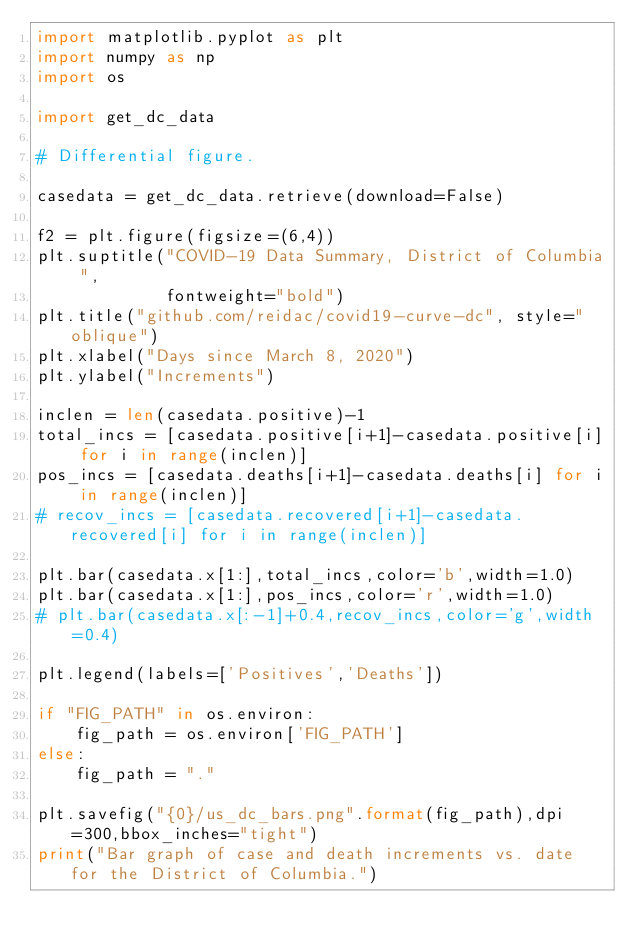Convert code to text. <code><loc_0><loc_0><loc_500><loc_500><_Python_>import matplotlib.pyplot as plt
import numpy as np
import os

import get_dc_data

# Differential figure.

casedata = get_dc_data.retrieve(download=False)

f2 = plt.figure(figsize=(6,4))
plt.suptitle("COVID-19 Data Summary, District of Columbia ",
             fontweight="bold")
plt.title("github.com/reidac/covid19-curve-dc", style="oblique")
plt.xlabel("Days since March 8, 2020")
plt.ylabel("Increments")

inclen = len(casedata.positive)-1
total_incs = [casedata.positive[i+1]-casedata.positive[i] for i in range(inclen)]
pos_incs = [casedata.deaths[i+1]-casedata.deaths[i] for i in range(inclen)]
# recov_incs = [casedata.recovered[i+1]-casedata.recovered[i] for i in range(inclen)]

plt.bar(casedata.x[1:],total_incs,color='b',width=1.0)
plt.bar(casedata.x[1:],pos_incs,color='r',width=1.0)
# plt.bar(casedata.x[:-1]+0.4,recov_incs,color='g',width=0.4)

plt.legend(labels=['Positives','Deaths'])

if "FIG_PATH" in os.environ:
    fig_path = os.environ['FIG_PATH']
else:
    fig_path = "."

plt.savefig("{0}/us_dc_bars.png".format(fig_path),dpi=300,bbox_inches="tight")
print("Bar graph of case and death increments vs. date for the District of Columbia.")
</code> 